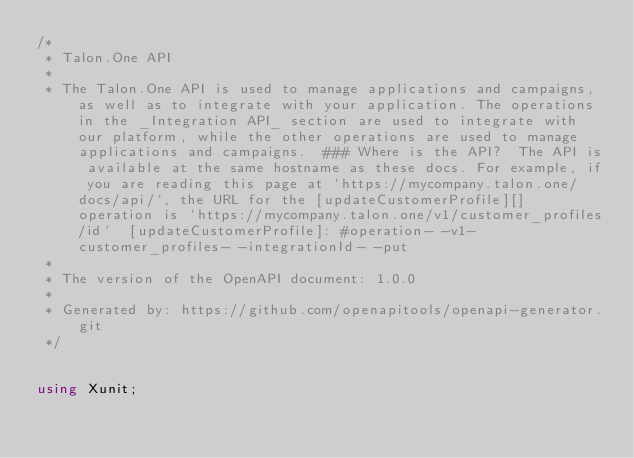Convert code to text. <code><loc_0><loc_0><loc_500><loc_500><_C#_>/* 
 * Talon.One API
 *
 * The Talon.One API is used to manage applications and campaigns, as well as to integrate with your application. The operations in the _Integration API_ section are used to integrate with our platform, while the other operations are used to manage applications and campaigns.  ### Where is the API?  The API is available at the same hostname as these docs. For example, if you are reading this page at `https://mycompany.talon.one/docs/api/`, the URL for the [updateCustomerProfile][] operation is `https://mycompany.talon.one/v1/customer_profiles/id`  [updateCustomerProfile]: #operation- -v1-customer_profiles- -integrationId- -put 
 *
 * The version of the OpenAPI document: 1.0.0
 * 
 * Generated by: https://github.com/openapitools/openapi-generator.git
 */


using Xunit;
</code> 